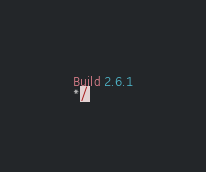<code> <loc_0><loc_0><loc_500><loc_500><_JavaScript_>Build 2.6.1
*/</code> 